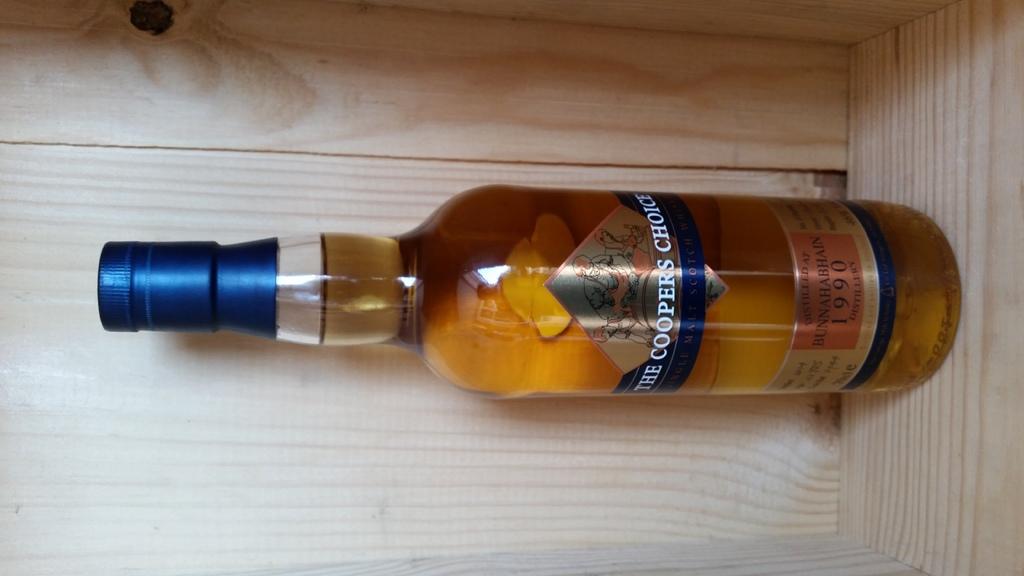What is the brand name on the bottle?
Your answer should be very brief. The coopers choice. 